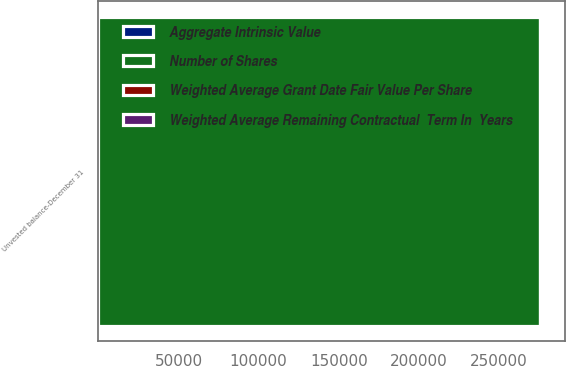Convert chart. <chart><loc_0><loc_0><loc_500><loc_500><stacked_bar_chart><ecel><fcel>Unvested balance-December 31<nl><fcel>Weighted Average Remaining Contractual  Term In  Years<fcel>1308<nl><fcel>Weighted Average Grant Date Fair Value Per Share<fcel>150.6<nl><fcel>Aggregate Intrinsic Value<fcel>1.5<nl><fcel>Number of Shares<fcel>275638<nl></chart> 